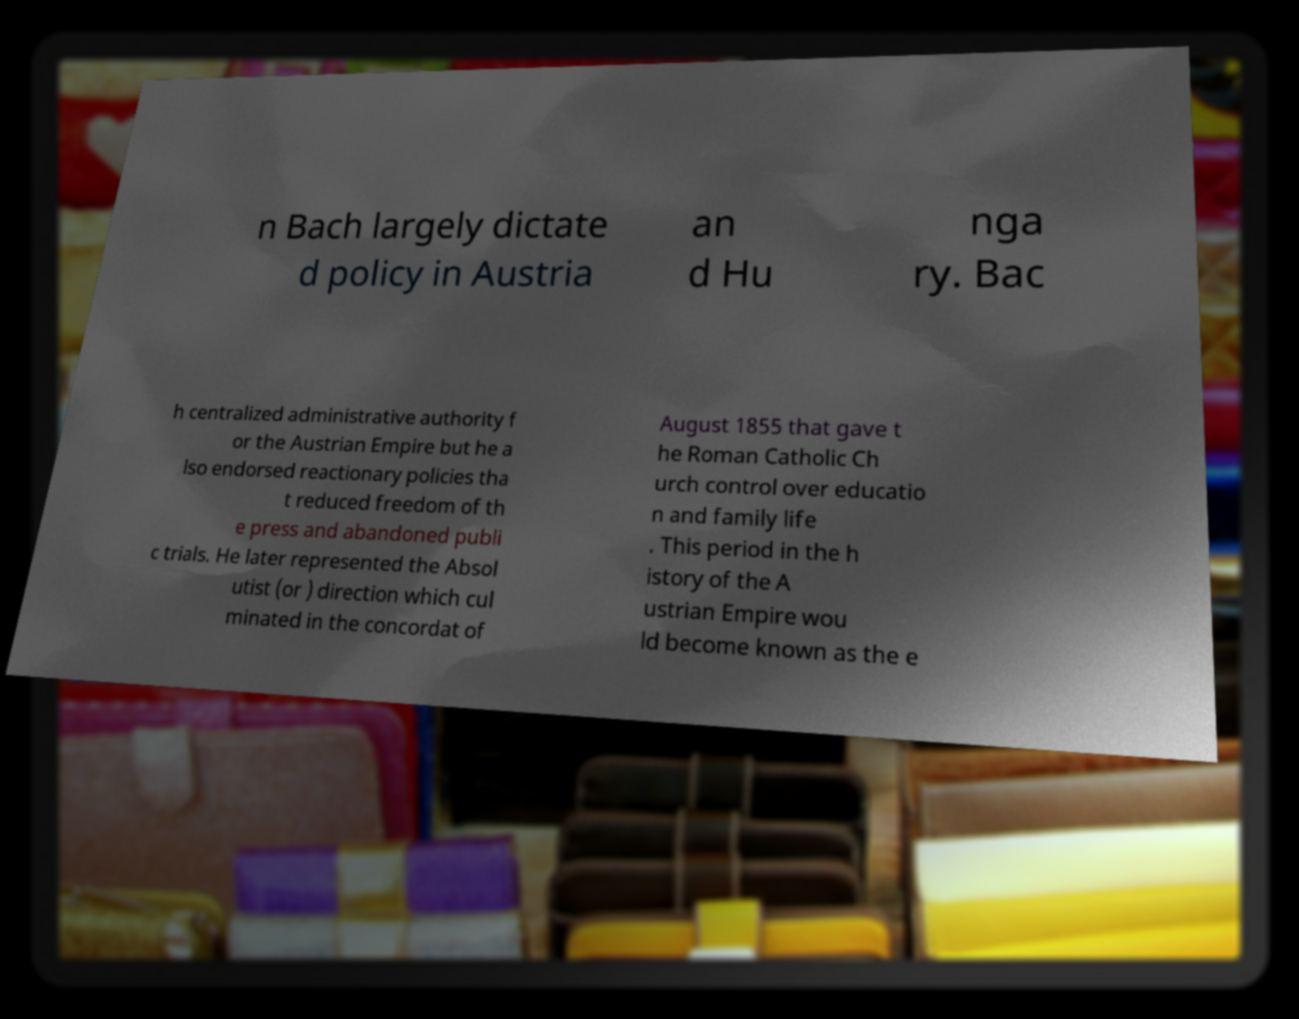For documentation purposes, I need the text within this image transcribed. Could you provide that? n Bach largely dictate d policy in Austria an d Hu nga ry. Bac h centralized administrative authority f or the Austrian Empire but he a lso endorsed reactionary policies tha t reduced freedom of th e press and abandoned publi c trials. He later represented the Absol utist (or ) direction which cul minated in the concordat of August 1855 that gave t he Roman Catholic Ch urch control over educatio n and family life . This period in the h istory of the A ustrian Empire wou ld become known as the e 